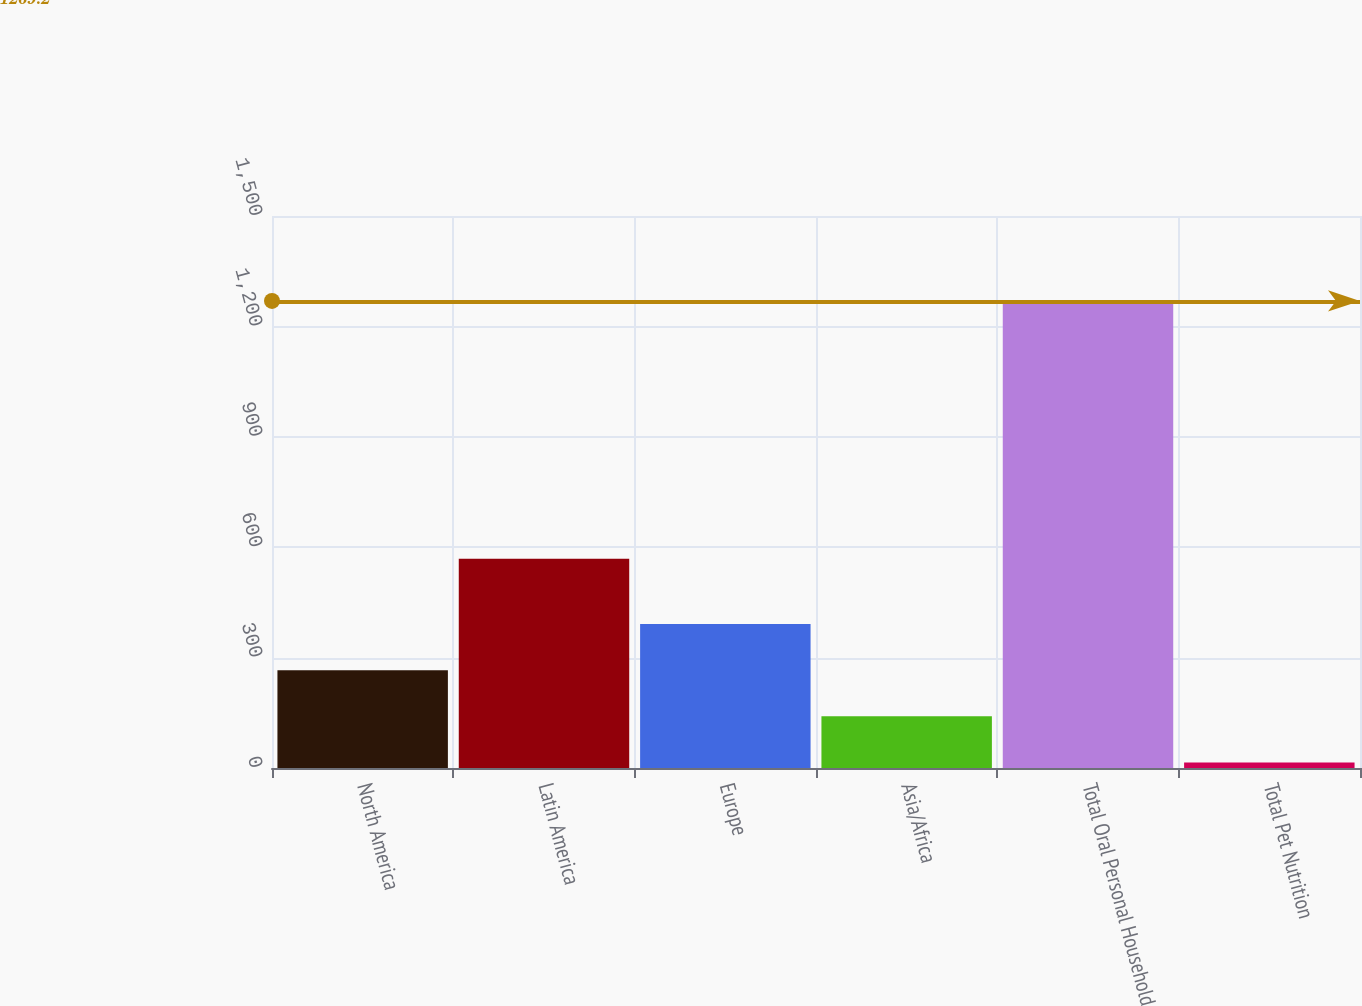Convert chart to OTSL. <chart><loc_0><loc_0><loc_500><loc_500><bar_chart><fcel>North America<fcel>Latin America<fcel>Europe<fcel>Asia/Africa<fcel>Total Oral Personal Household<fcel>Total Pet Nutrition<nl><fcel>265.84<fcel>568.7<fcel>391.26<fcel>140.42<fcel>1269.2<fcel>15<nl></chart> 